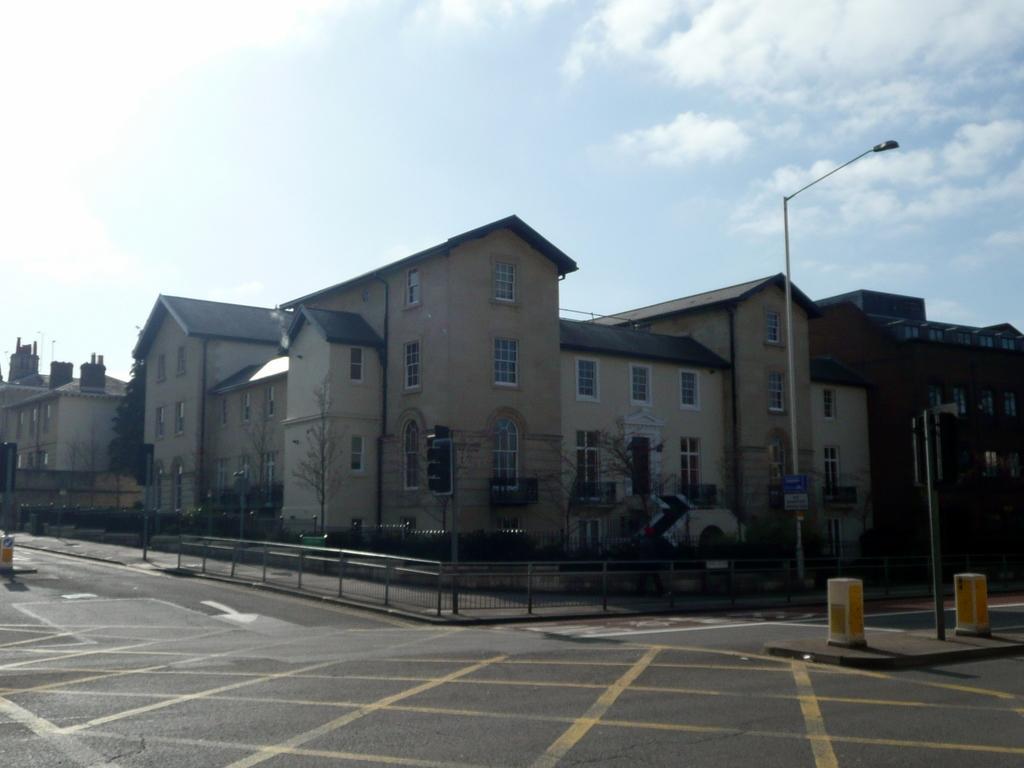Can you describe this image briefly? In this image there is a road, in the background there is a railing, light poles, trees, buildings and the sky. 